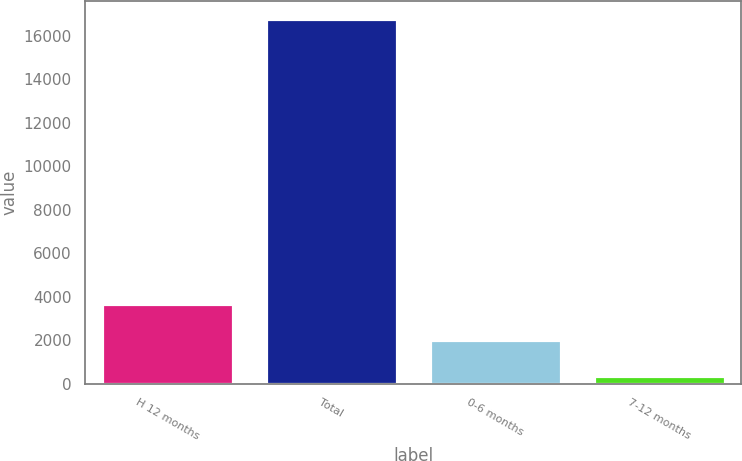Convert chart. <chart><loc_0><loc_0><loc_500><loc_500><bar_chart><fcel>H 12 months<fcel>Total<fcel>0-6 months<fcel>7-12 months<nl><fcel>3664<fcel>16772<fcel>2025.5<fcel>387<nl></chart> 